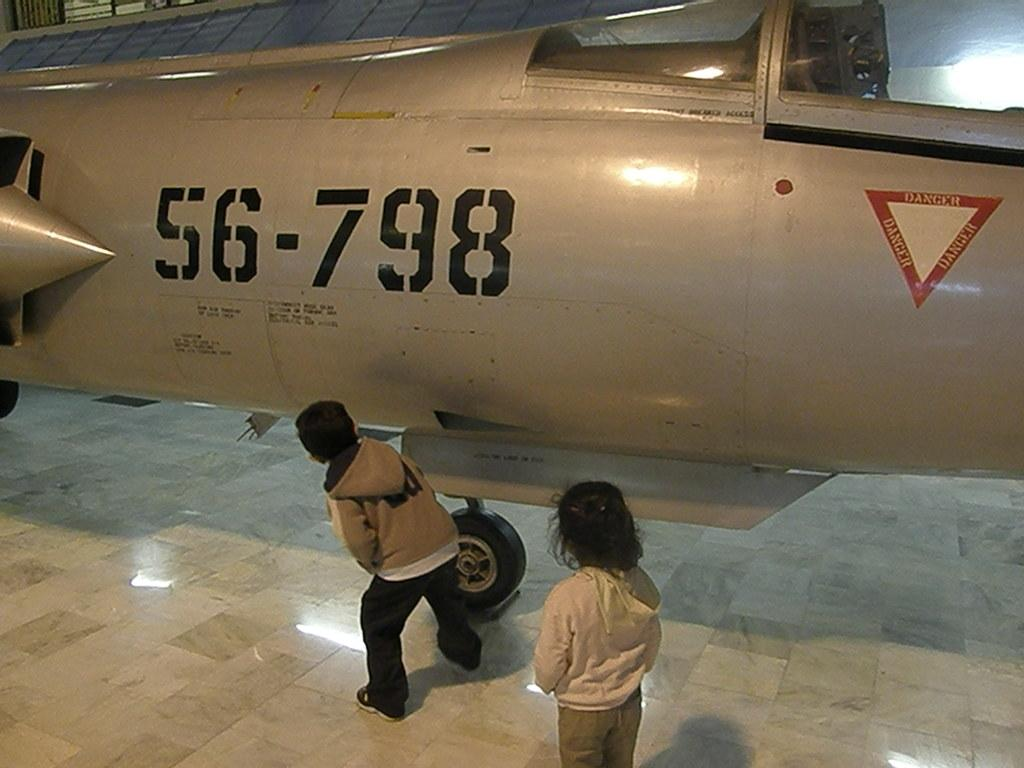<image>
Relay a brief, clear account of the picture shown. An airplane sits inside of a building with the numbers 56-798 on it. 